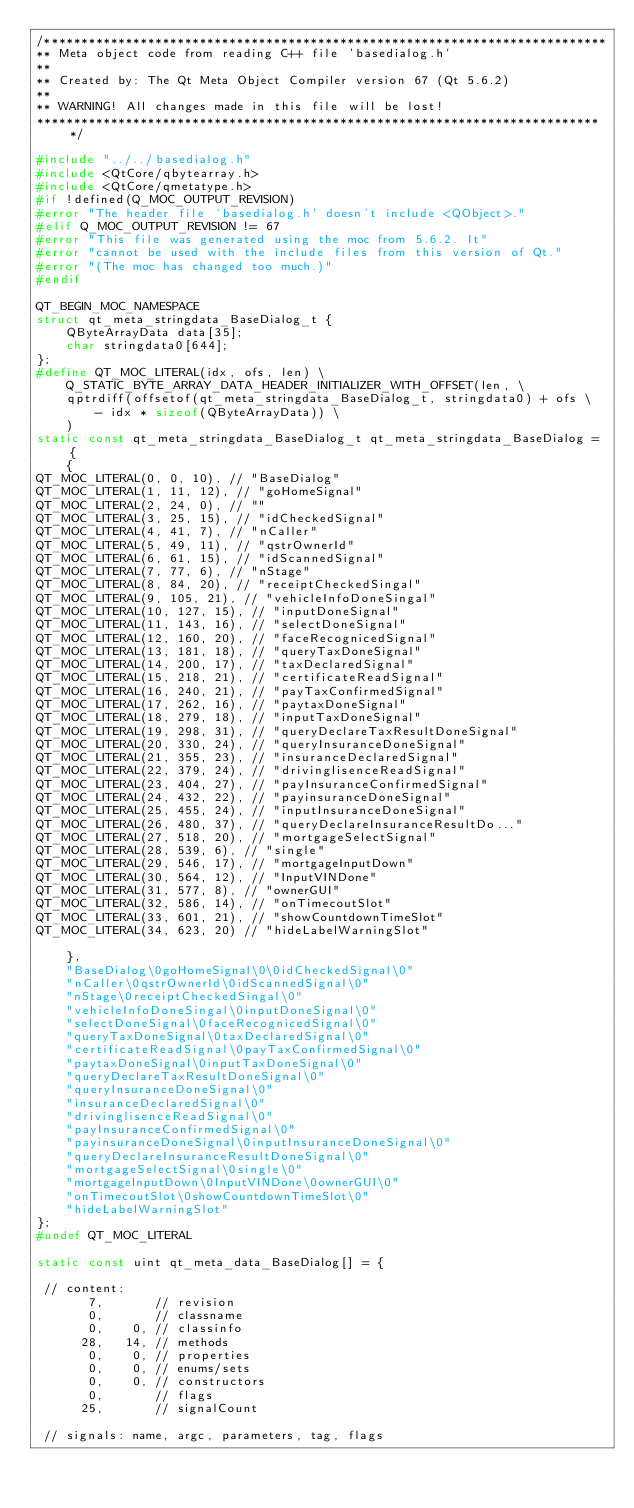<code> <loc_0><loc_0><loc_500><loc_500><_C++_>/****************************************************************************
** Meta object code from reading C++ file 'basedialog.h'
**
** Created by: The Qt Meta Object Compiler version 67 (Qt 5.6.2)
**
** WARNING! All changes made in this file will be lost!
*****************************************************************************/

#include "../../basedialog.h"
#include <QtCore/qbytearray.h>
#include <QtCore/qmetatype.h>
#if !defined(Q_MOC_OUTPUT_REVISION)
#error "The header file 'basedialog.h' doesn't include <QObject>."
#elif Q_MOC_OUTPUT_REVISION != 67
#error "This file was generated using the moc from 5.6.2. It"
#error "cannot be used with the include files from this version of Qt."
#error "(The moc has changed too much.)"
#endif

QT_BEGIN_MOC_NAMESPACE
struct qt_meta_stringdata_BaseDialog_t {
    QByteArrayData data[35];
    char stringdata0[644];
};
#define QT_MOC_LITERAL(idx, ofs, len) \
    Q_STATIC_BYTE_ARRAY_DATA_HEADER_INITIALIZER_WITH_OFFSET(len, \
    qptrdiff(offsetof(qt_meta_stringdata_BaseDialog_t, stringdata0) + ofs \
        - idx * sizeof(QByteArrayData)) \
    )
static const qt_meta_stringdata_BaseDialog_t qt_meta_stringdata_BaseDialog = {
    {
QT_MOC_LITERAL(0, 0, 10), // "BaseDialog"
QT_MOC_LITERAL(1, 11, 12), // "goHomeSignal"
QT_MOC_LITERAL(2, 24, 0), // ""
QT_MOC_LITERAL(3, 25, 15), // "idCheckedSignal"
QT_MOC_LITERAL(4, 41, 7), // "nCaller"
QT_MOC_LITERAL(5, 49, 11), // "qstrOwnerId"
QT_MOC_LITERAL(6, 61, 15), // "idScannedSignal"
QT_MOC_LITERAL(7, 77, 6), // "nStage"
QT_MOC_LITERAL(8, 84, 20), // "receiptCheckedSingal"
QT_MOC_LITERAL(9, 105, 21), // "vehicleInfoDoneSingal"
QT_MOC_LITERAL(10, 127, 15), // "inputDoneSignal"
QT_MOC_LITERAL(11, 143, 16), // "selectDoneSignal"
QT_MOC_LITERAL(12, 160, 20), // "faceRecognicedSignal"
QT_MOC_LITERAL(13, 181, 18), // "queryTaxDoneSignal"
QT_MOC_LITERAL(14, 200, 17), // "taxDeclaredSignal"
QT_MOC_LITERAL(15, 218, 21), // "certificateReadSignal"
QT_MOC_LITERAL(16, 240, 21), // "payTaxConfirmedSignal"
QT_MOC_LITERAL(17, 262, 16), // "paytaxDoneSignal"
QT_MOC_LITERAL(18, 279, 18), // "inputTaxDoneSignal"
QT_MOC_LITERAL(19, 298, 31), // "queryDeclareTaxResultDoneSignal"
QT_MOC_LITERAL(20, 330, 24), // "queryInsuranceDoneSignal"
QT_MOC_LITERAL(21, 355, 23), // "insuranceDeclaredSignal"
QT_MOC_LITERAL(22, 379, 24), // "drivinglisenceReadSignal"
QT_MOC_LITERAL(23, 404, 27), // "payInsuranceConfirmedSignal"
QT_MOC_LITERAL(24, 432, 22), // "payinsuranceDoneSignal"
QT_MOC_LITERAL(25, 455, 24), // "inputInsuranceDoneSignal"
QT_MOC_LITERAL(26, 480, 37), // "queryDeclareInsuranceResultDo..."
QT_MOC_LITERAL(27, 518, 20), // "mortgageSelectSignal"
QT_MOC_LITERAL(28, 539, 6), // "single"
QT_MOC_LITERAL(29, 546, 17), // "mortgageInputDown"
QT_MOC_LITERAL(30, 564, 12), // "InputVINDone"
QT_MOC_LITERAL(31, 577, 8), // "ownerGUI"
QT_MOC_LITERAL(32, 586, 14), // "onTimecoutSlot"
QT_MOC_LITERAL(33, 601, 21), // "showCountdownTimeSlot"
QT_MOC_LITERAL(34, 623, 20) // "hideLabelWarningSlot"

    },
    "BaseDialog\0goHomeSignal\0\0idCheckedSignal\0"
    "nCaller\0qstrOwnerId\0idScannedSignal\0"
    "nStage\0receiptCheckedSingal\0"
    "vehicleInfoDoneSingal\0inputDoneSignal\0"
    "selectDoneSignal\0faceRecognicedSignal\0"
    "queryTaxDoneSignal\0taxDeclaredSignal\0"
    "certificateReadSignal\0payTaxConfirmedSignal\0"
    "paytaxDoneSignal\0inputTaxDoneSignal\0"
    "queryDeclareTaxResultDoneSignal\0"
    "queryInsuranceDoneSignal\0"
    "insuranceDeclaredSignal\0"
    "drivinglisenceReadSignal\0"
    "payInsuranceConfirmedSignal\0"
    "payinsuranceDoneSignal\0inputInsuranceDoneSignal\0"
    "queryDeclareInsuranceResultDoneSignal\0"
    "mortgageSelectSignal\0single\0"
    "mortgageInputDown\0InputVINDone\0ownerGUI\0"
    "onTimecoutSlot\0showCountdownTimeSlot\0"
    "hideLabelWarningSlot"
};
#undef QT_MOC_LITERAL

static const uint qt_meta_data_BaseDialog[] = {

 // content:
       7,       // revision
       0,       // classname
       0,    0, // classinfo
      28,   14, // methods
       0,    0, // properties
       0,    0, // enums/sets
       0,    0, // constructors
       0,       // flags
      25,       // signalCount

 // signals: name, argc, parameters, tag, flags</code> 